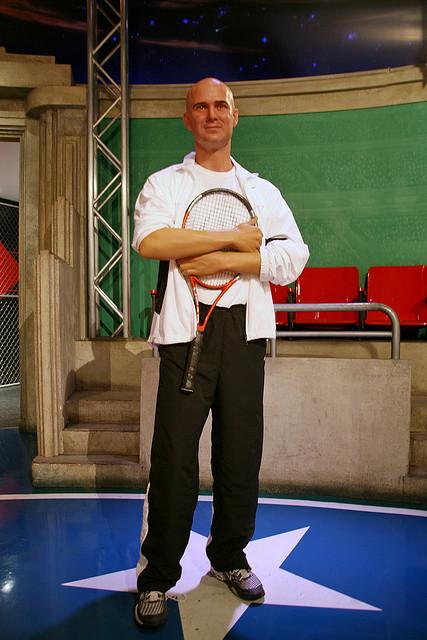What is the boy holding?
Keep it brief. Racket. What color is the star?
Answer briefly. White. What shape is painted on the floor?
Quick response, please. Star. Is this player going to hit the ball?
Concise answer only. No. Has he been playing very hard?
Quick response, please. No. What is he holding?
Be succinct. Tennis racket. What is the brand of tennis racket in the coach's arms?
Give a very brief answer. Wilson. Why is the man swinging the racquet?
Write a very short answer. He isn't. Is he throwing the ball yet?
Answer briefly. No. 